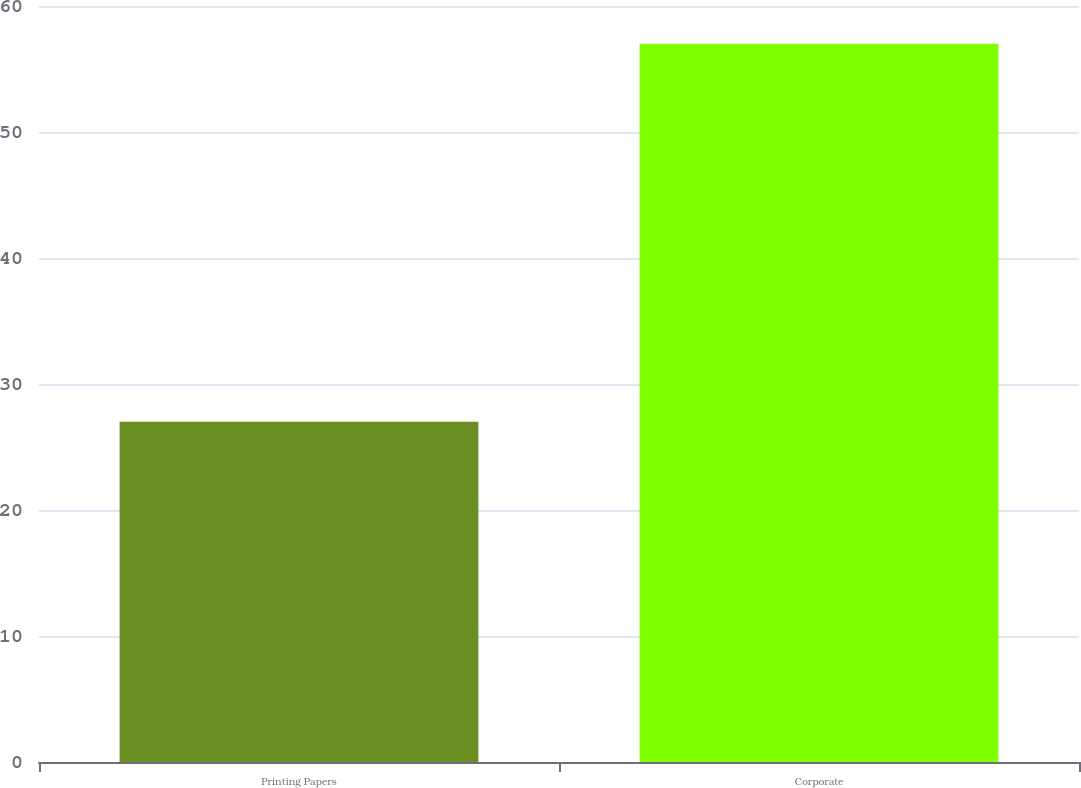Convert chart. <chart><loc_0><loc_0><loc_500><loc_500><bar_chart><fcel>Printing Papers<fcel>Corporate<nl><fcel>27<fcel>57<nl></chart> 